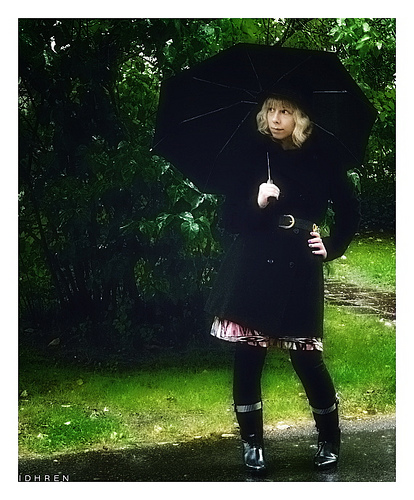Identify the text displayed in this image. SHREN 